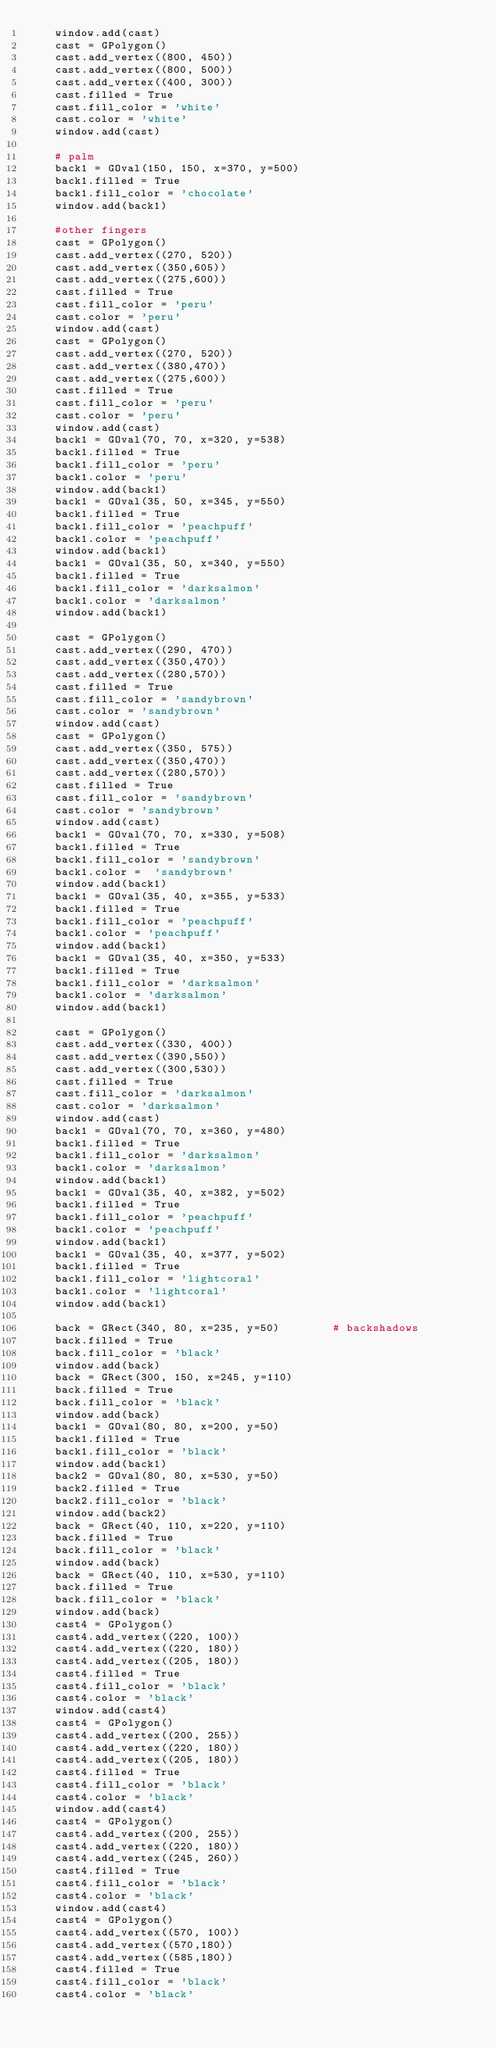<code> <loc_0><loc_0><loc_500><loc_500><_Python_>    window.add(cast)
    cast = GPolygon()
    cast.add_vertex((800, 450))
    cast.add_vertex((800, 500))
    cast.add_vertex((400, 300))
    cast.filled = True
    cast.fill_color = 'white'
    cast.color = 'white'
    window.add(cast)

    # palm
    back1 = GOval(150, 150, x=370, y=500)
    back1.filled = True
    back1.fill_color = 'chocolate'
    window.add(back1)

    #other fingers
    cast = GPolygon()
    cast.add_vertex((270, 520))
    cast.add_vertex((350,605))
    cast.add_vertex((275,600))
    cast.filled = True
    cast.fill_color = 'peru'
    cast.color = 'peru'
    window.add(cast)
    cast = GPolygon()
    cast.add_vertex((270, 520))
    cast.add_vertex((380,470))
    cast.add_vertex((275,600))
    cast.filled = True
    cast.fill_color = 'peru'
    cast.color = 'peru'
    window.add(cast)
    back1 = GOval(70, 70, x=320, y=538)
    back1.filled = True
    back1.fill_color = 'peru'
    back1.color = 'peru'
    window.add(back1)
    back1 = GOval(35, 50, x=345, y=550)
    back1.filled = True
    back1.fill_color = 'peachpuff'
    back1.color = 'peachpuff'
    window.add(back1)
    back1 = GOval(35, 50, x=340, y=550)
    back1.filled = True
    back1.fill_color = 'darksalmon'
    back1.color = 'darksalmon'
    window.add(back1)

    cast = GPolygon()
    cast.add_vertex((290, 470))
    cast.add_vertex((350,470))
    cast.add_vertex((280,570))
    cast.filled = True
    cast.fill_color = 'sandybrown'
    cast.color = 'sandybrown'
    window.add(cast)
    cast = GPolygon()
    cast.add_vertex((350, 575))
    cast.add_vertex((350,470))
    cast.add_vertex((280,570))
    cast.filled = True
    cast.fill_color = 'sandybrown'
    cast.color = 'sandybrown'
    window.add(cast)
    back1 = GOval(70, 70, x=330, y=508)
    back1.filled = True
    back1.fill_color = 'sandybrown'
    back1.color =  'sandybrown'
    window.add(back1)
    back1 = GOval(35, 40, x=355, y=533)
    back1.filled = True
    back1.fill_color = 'peachpuff'
    back1.color = 'peachpuff'
    window.add(back1)
    back1 = GOval(35, 40, x=350, y=533)
    back1.filled = True
    back1.fill_color = 'darksalmon'
    back1.color = 'darksalmon'
    window.add(back1)

    cast = GPolygon()
    cast.add_vertex((330, 400))
    cast.add_vertex((390,550))
    cast.add_vertex((300,530))
    cast.filled = True
    cast.fill_color = 'darksalmon'
    cast.color = 'darksalmon'
    window.add(cast)
    back1 = GOval(70, 70, x=360, y=480)
    back1.filled = True
    back1.fill_color = 'darksalmon'
    back1.color = 'darksalmon'
    window.add(back1)
    back1 = GOval(35, 40, x=382, y=502)
    back1.filled = True
    back1.fill_color = 'peachpuff'
    back1.color = 'peachpuff'
    window.add(back1)
    back1 = GOval(35, 40, x=377, y=502)
    back1.filled = True
    back1.fill_color = 'lightcoral'
    back1.color = 'lightcoral'
    window.add(back1)

    back = GRect(340, 80, x=235, y=50)        # backshadows
    back.filled = True
    back.fill_color = 'black'
    window.add(back)
    back = GRect(300, 150, x=245, y=110)
    back.filled = True
    back.fill_color = 'black'
    window.add(back)
    back1 = GOval(80, 80, x=200, y=50)
    back1.filled = True
    back1.fill_color = 'black'
    window.add(back1)
    back2 = GOval(80, 80, x=530, y=50)
    back2.filled = True
    back2.fill_color = 'black'
    window.add(back2)
    back = GRect(40, 110, x=220, y=110)
    back.filled = True
    back.fill_color = 'black'
    window.add(back)
    back = GRect(40, 110, x=530, y=110)
    back.filled = True
    back.fill_color = 'black'
    window.add(back)
    cast4 = GPolygon()
    cast4.add_vertex((220, 100))
    cast4.add_vertex((220, 180))
    cast4.add_vertex((205, 180))
    cast4.filled = True
    cast4.fill_color = 'black'
    cast4.color = 'black'
    window.add(cast4)
    cast4 = GPolygon()
    cast4.add_vertex((200, 255))
    cast4.add_vertex((220, 180))
    cast4.add_vertex((205, 180))
    cast4.filled = True
    cast4.fill_color = 'black'
    cast4.color = 'black'
    window.add(cast4)
    cast4 = GPolygon()
    cast4.add_vertex((200, 255))
    cast4.add_vertex((220, 180))
    cast4.add_vertex((245, 260))
    cast4.filled = True
    cast4.fill_color = 'black'
    cast4.color = 'black'
    window.add(cast4)
    cast4 = GPolygon()
    cast4.add_vertex((570, 100))
    cast4.add_vertex((570,180))
    cast4.add_vertex((585,180))
    cast4.filled = True
    cast4.fill_color = 'black'
    cast4.color = 'black'</code> 